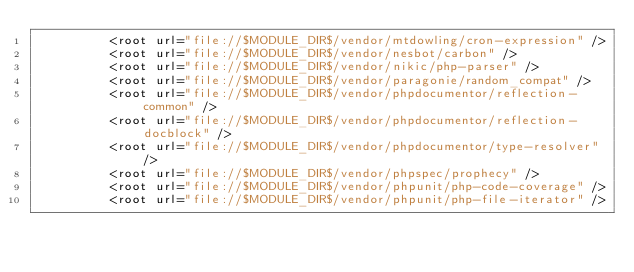<code> <loc_0><loc_0><loc_500><loc_500><_XML_>          <root url="file://$MODULE_DIR$/vendor/mtdowling/cron-expression" />
          <root url="file://$MODULE_DIR$/vendor/nesbot/carbon" />
          <root url="file://$MODULE_DIR$/vendor/nikic/php-parser" />
          <root url="file://$MODULE_DIR$/vendor/paragonie/random_compat" />
          <root url="file://$MODULE_DIR$/vendor/phpdocumentor/reflection-common" />
          <root url="file://$MODULE_DIR$/vendor/phpdocumentor/reflection-docblock" />
          <root url="file://$MODULE_DIR$/vendor/phpdocumentor/type-resolver" />
          <root url="file://$MODULE_DIR$/vendor/phpspec/prophecy" />
          <root url="file://$MODULE_DIR$/vendor/phpunit/php-code-coverage" />
          <root url="file://$MODULE_DIR$/vendor/phpunit/php-file-iterator" /></code> 